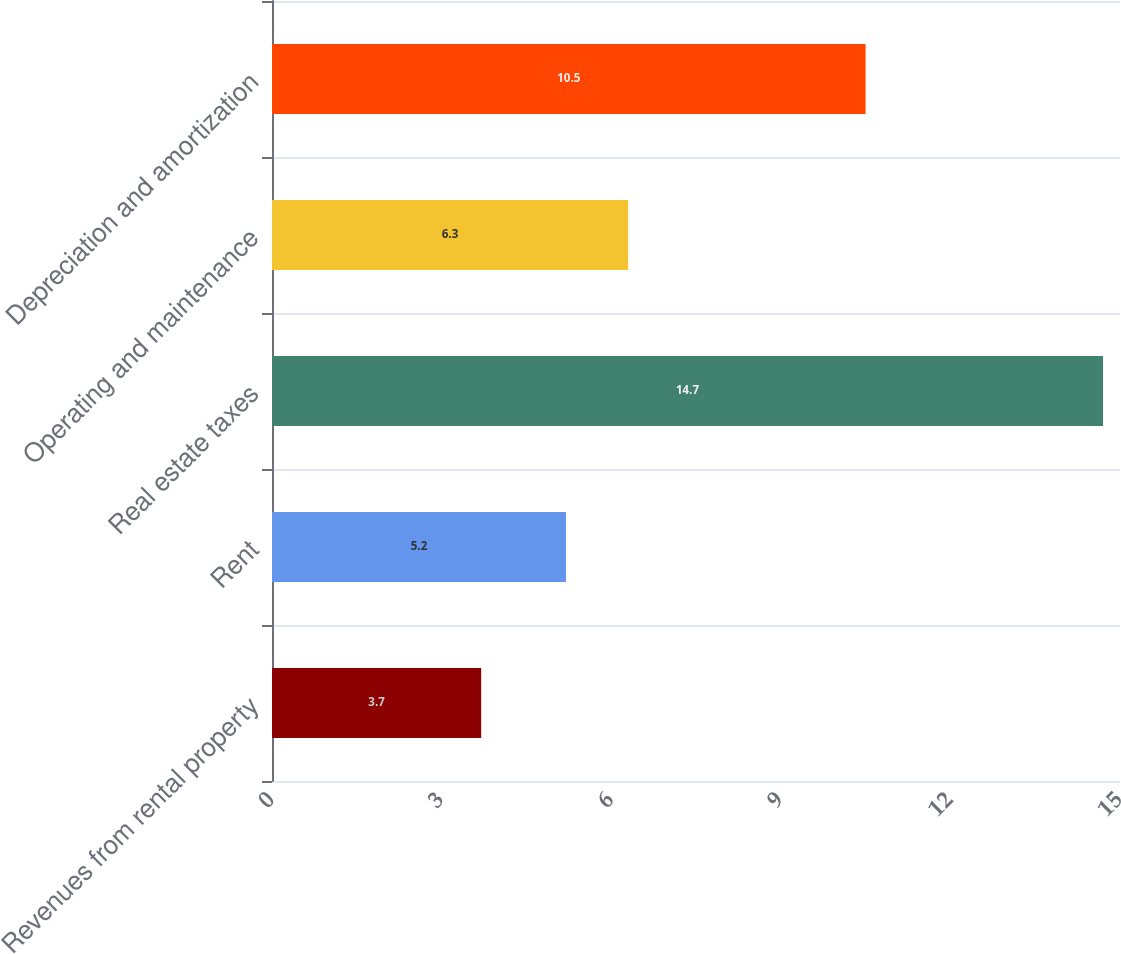Convert chart to OTSL. <chart><loc_0><loc_0><loc_500><loc_500><bar_chart><fcel>Revenues from rental property<fcel>Rent<fcel>Real estate taxes<fcel>Operating and maintenance<fcel>Depreciation and amortization<nl><fcel>3.7<fcel>5.2<fcel>14.7<fcel>6.3<fcel>10.5<nl></chart> 